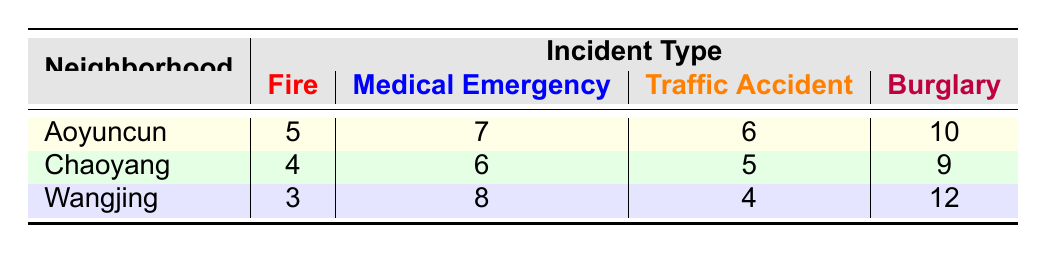What is the response time for fire incidents in Aoyuncun? From the table, the response time for fire incidents in Aoyuncun is found in the row corresponding to Aoyuncun under the Fire column, which shows a value of 5 minutes.
Answer: 5 Which neighborhood has the longest response time for medical emergencies? To determine this, we look at the Medical Emergency column for each neighborhood: Aoyuncun has 7 minutes, Chaoyang has 6 minutes, and Wangjing has 8 minutes. Wangjing has the highest value of 8 minutes.
Answer: Wangjing What is the average response time for traffic accidents across all neighborhoods? The response times for traffic accidents are: Aoyuncun (6), Chaoyang (5), and Wangjing (4). The average is calculated as (6 + 5 + 4) / 3 = 15 / 3 = 5.
Answer: 5 Is the response time for burglaries in Chaoyang less than that in Aoyuncun? Looking at the Burglary column, Chaoyang has a response time of 9 minutes, while Aoyuncun has 10 minutes. Since 9 is less than 10, the statement is true.
Answer: Yes Which incident type has the highest response time in Aoyuncun? The response times in Aoyuncun are 5 for Fire, 7 for Medical Emergency, 6 for Traffic Accident, and 10 for Burglary. The highest value is in the Burglary row at 10 minutes.
Answer: Burglary If you combine the response times for all incident types in Wangjing, what is the total? The individual response times in Wangjing are: Fire (3), Medical Emergency (8), Traffic Accident (4), and Burglary (12). Summing these gives 3 + 8 + 4 + 12 = 27.
Answer: 27 Are the response times for any incident type in Chaoyang shorter than those in Aoyuncun? For Chaoyang, the times are: Fire (4), Medical Emergency (6), Traffic Accident (5), Burglary (9). For Aoyuncun, the times are: Fire (5), Medical Emergency (7), Traffic Accident (6), Burglary (10). Comparing, Fire (4 < 5), Medical Emergency (6 < 7), and Traffic Accident (5 < 6), which means all three are indeed shorter.
Answer: Yes What is the difference in response times for fire incidents between Wangjing and Chaoyang? Wangjing has a response time of 3 minutes and Chaoyang has 4 minutes. The difference is calculated by subtracting Wangjing's time from Chaoyang's, 4 - 3 = 1 minute.
Answer: 1 Which neighborhood has the fastest response time for traffic accidents? The times for traffic accidents are: Aoyuncun (6), Chaoyang (5), and Wangjing (4). The fastest time is found in Wangjing, which has 4 minutes.
Answer: Wangjing 